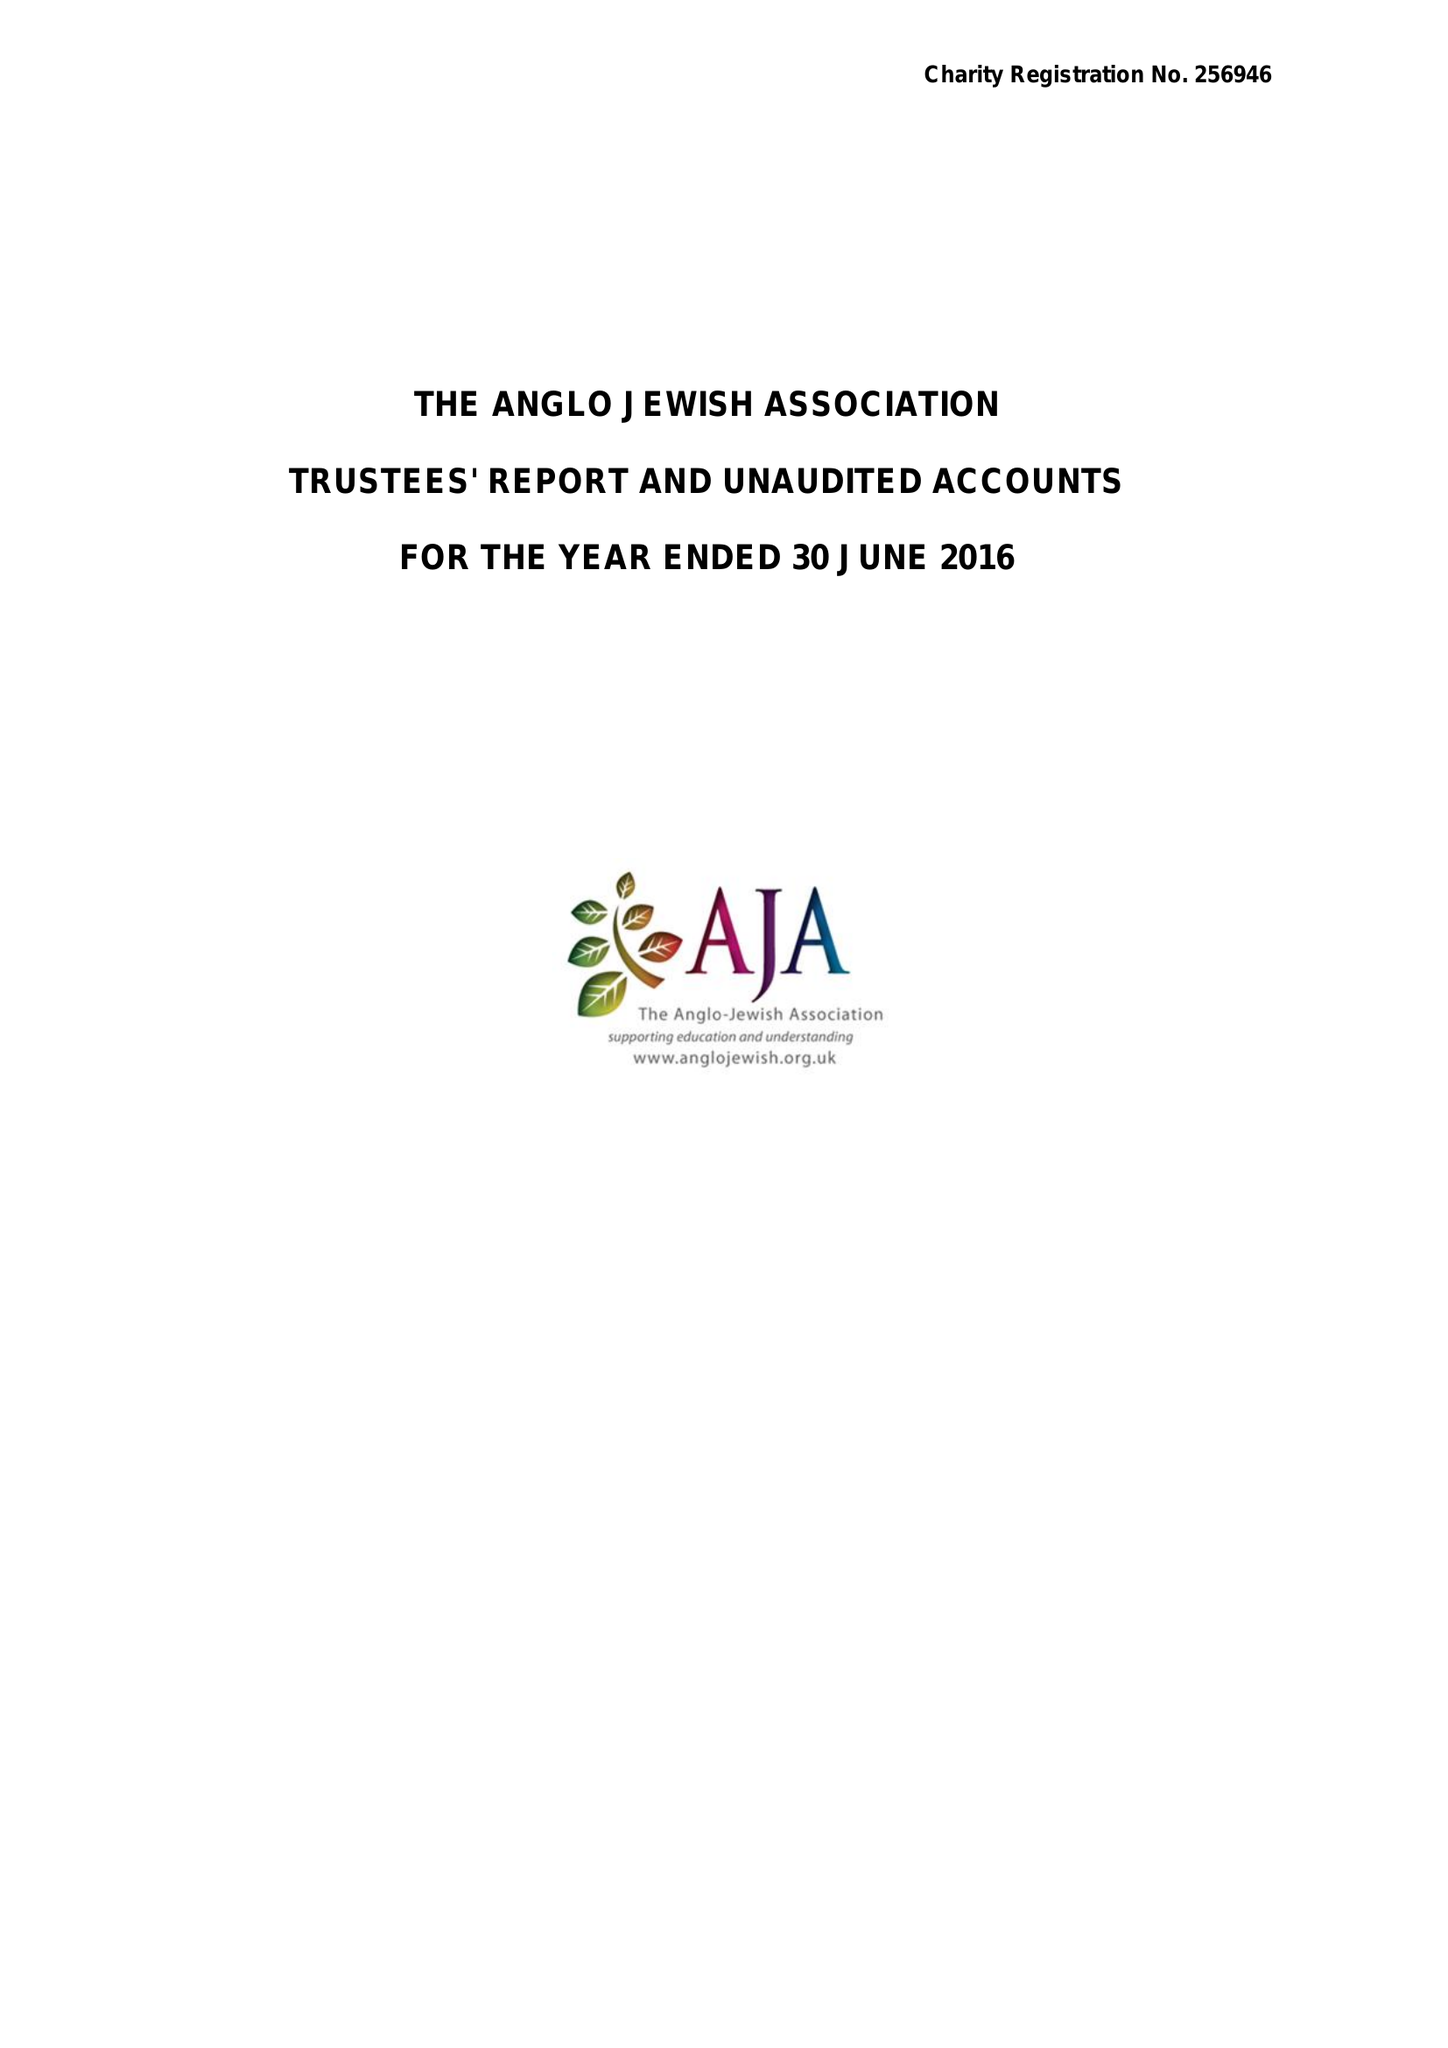What is the value for the address__street_line?
Answer the question using a single word or phrase. 75 MAYGROVE ROAD 